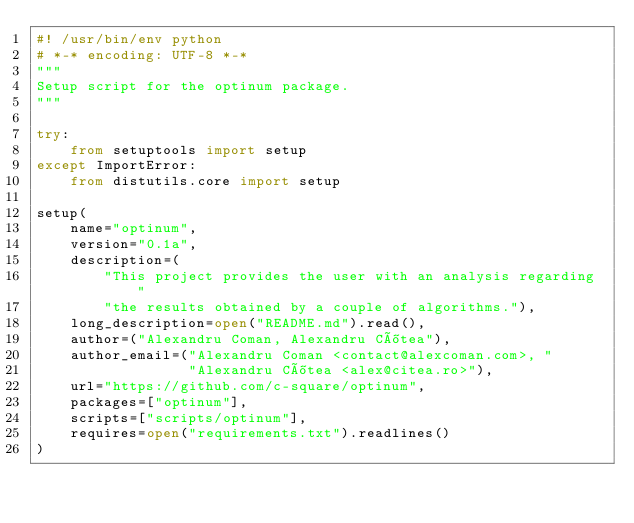<code> <loc_0><loc_0><loc_500><loc_500><_Python_>#! /usr/bin/env python
# *-* encoding: UTF-8 *-*
"""
Setup script for the optinum package.
"""

try:
    from setuptools import setup
except ImportError:
    from distutils.core import setup

setup(
    name="optinum",
    version="0.1a",
    description=(
        "This project provides the user with an analysis regarding "
        "the results obtained by a couple of algorithms."),
    long_description=open("README.md").read(),
    author=("Alexandru Coman, Alexandru Cîtea"),
    author_email=("Alexandru Coman <contact@alexcoman.com>, "
                  "Alexandru Cîtea <alex@citea.ro>"),
    url="https://github.com/c-square/optinum",
    packages=["optinum"],
    scripts=["scripts/optinum"],
    requires=open("requirements.txt").readlines()
)
</code> 